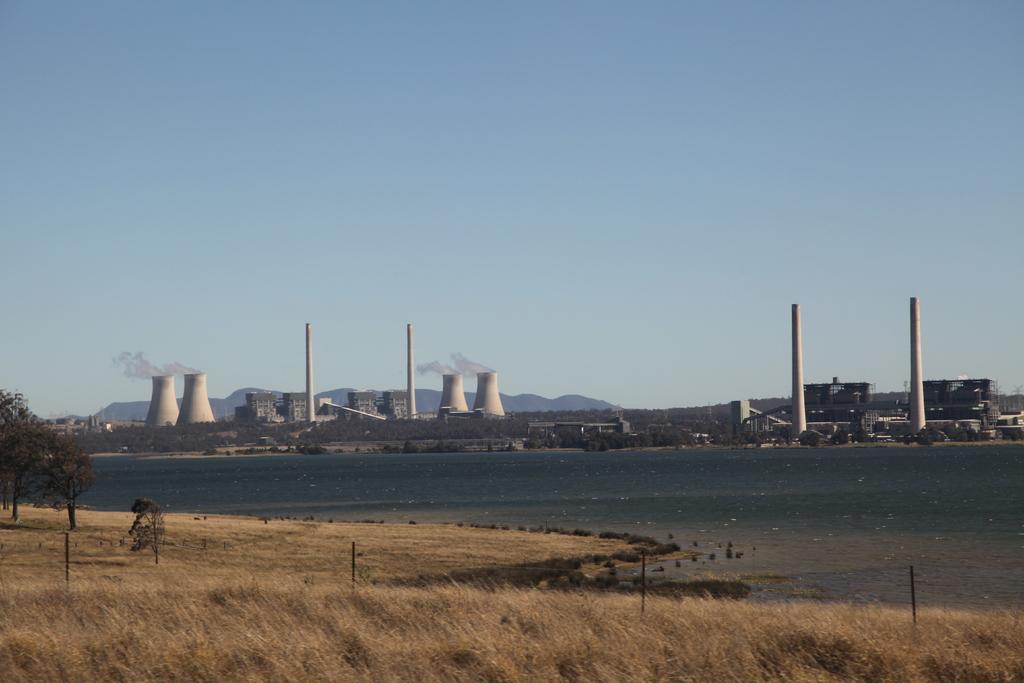Please provide a concise description of this image. In the foreground I can see grass, fence, trees, water and houses. In the background I can see power plants, mountains and the sky. This image is taken may be during a day. 